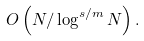Convert formula to latex. <formula><loc_0><loc_0><loc_500><loc_500>O \left ( N / \log ^ { s / m } N \right ) .</formula> 